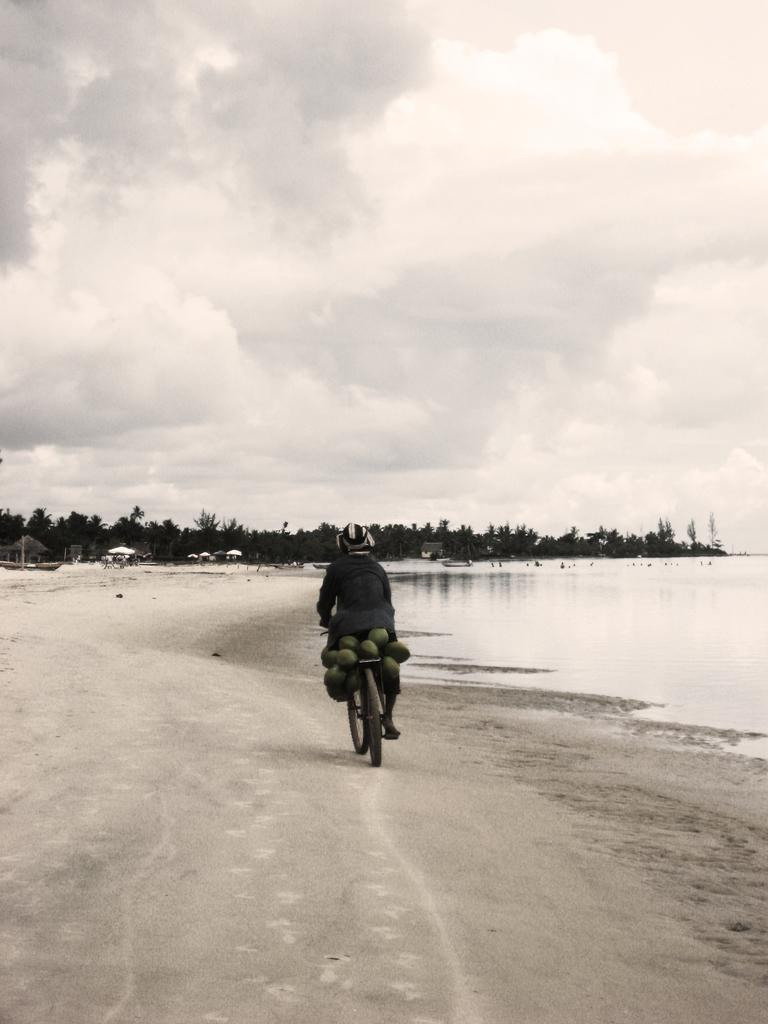Who is the main subject in the image? There is a guy in the image. What is the guy doing in the image? The guy is riding a cycle. What is the guy carrying on the back of his cycle? There are coconuts on the back of the guy. What can be seen in the background of the image? There is a sea visible to the right side of the image. What type of cloth is draped over the guy's legs while he is riding the cycle? There is no cloth draped over the guy's legs in the image. How many legs does the guy have while riding the cycle? The image does not show the guy's legs, so it is impossible to determine the number of legs. 